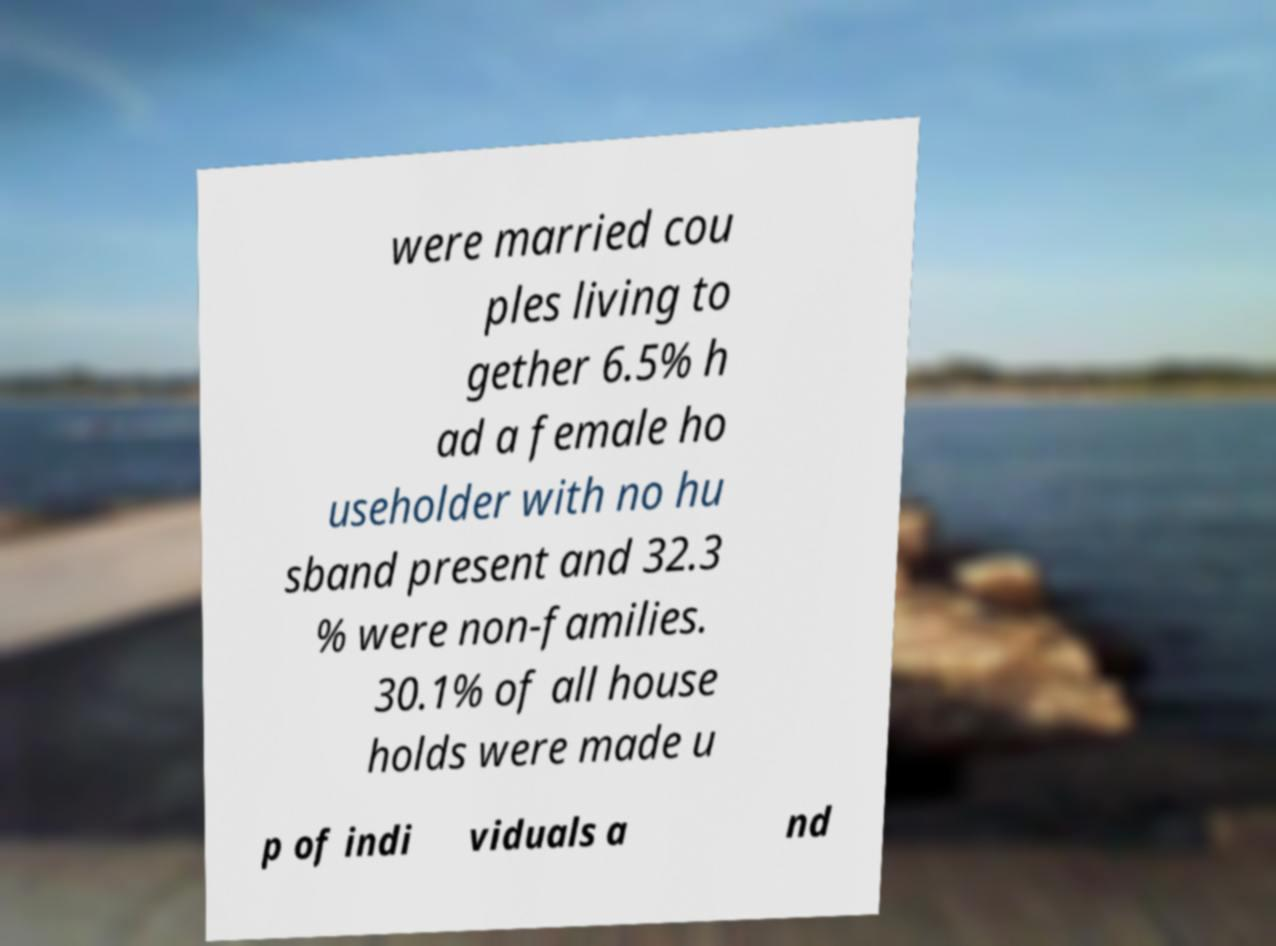Can you accurately transcribe the text from the provided image for me? were married cou ples living to gether 6.5% h ad a female ho useholder with no hu sband present and 32.3 % were non-families. 30.1% of all house holds were made u p of indi viduals a nd 